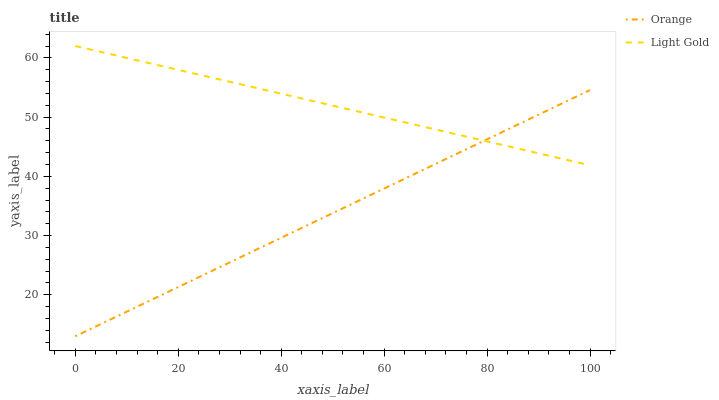Does Orange have the minimum area under the curve?
Answer yes or no. Yes. Does Light Gold have the maximum area under the curve?
Answer yes or no. Yes. Does Light Gold have the minimum area under the curve?
Answer yes or no. No. Is Orange the smoothest?
Answer yes or no. Yes. Is Light Gold the roughest?
Answer yes or no. Yes. Is Light Gold the smoothest?
Answer yes or no. No. Does Orange have the lowest value?
Answer yes or no. Yes. Does Light Gold have the lowest value?
Answer yes or no. No. Does Light Gold have the highest value?
Answer yes or no. Yes. Does Orange intersect Light Gold?
Answer yes or no. Yes. Is Orange less than Light Gold?
Answer yes or no. No. Is Orange greater than Light Gold?
Answer yes or no. No. 